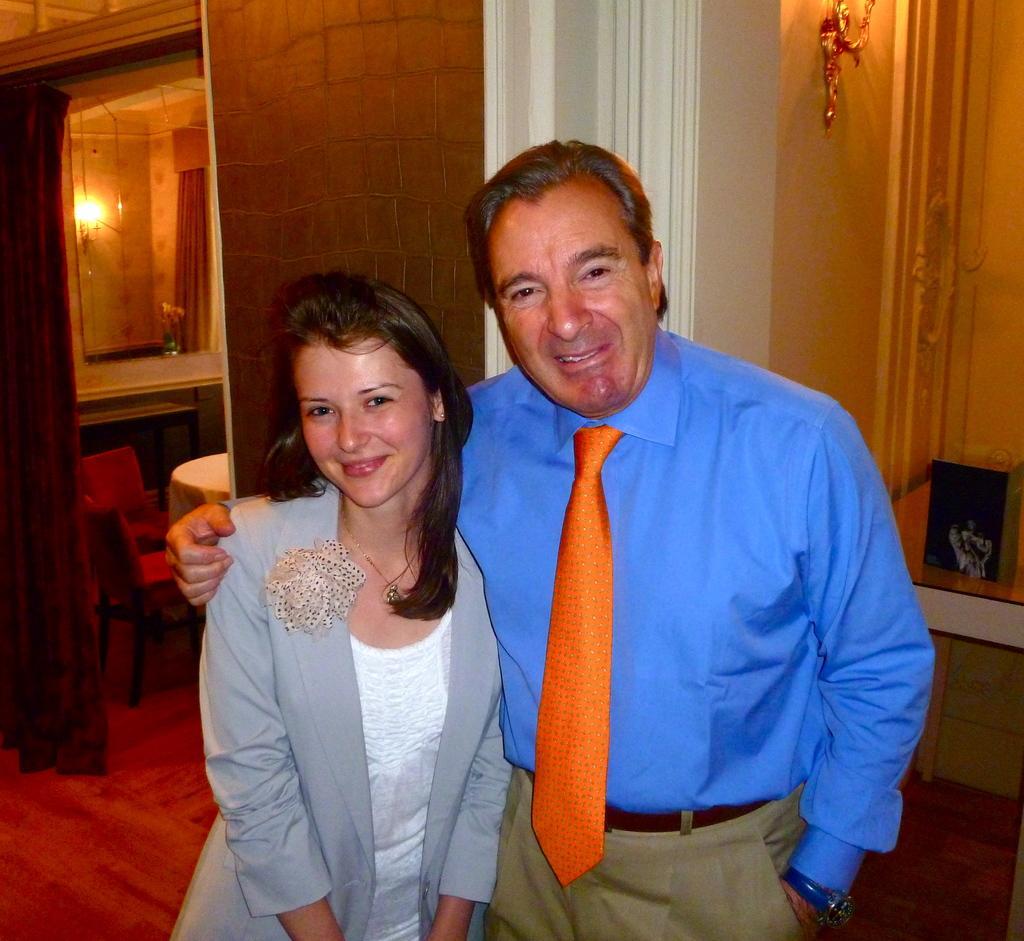Describe this image in one or two sentences. In this picture in the front there are persons standing and smiling. In the background there are empty chairs and table which is covered with a white colour cloth and there is a curtain and there is a partition wall, there is a pillar which is white in colour and on the wall there is a light and there is a mirror on the wall. On the right side in the background there is a table and on the table there is an object which is black in colour. 